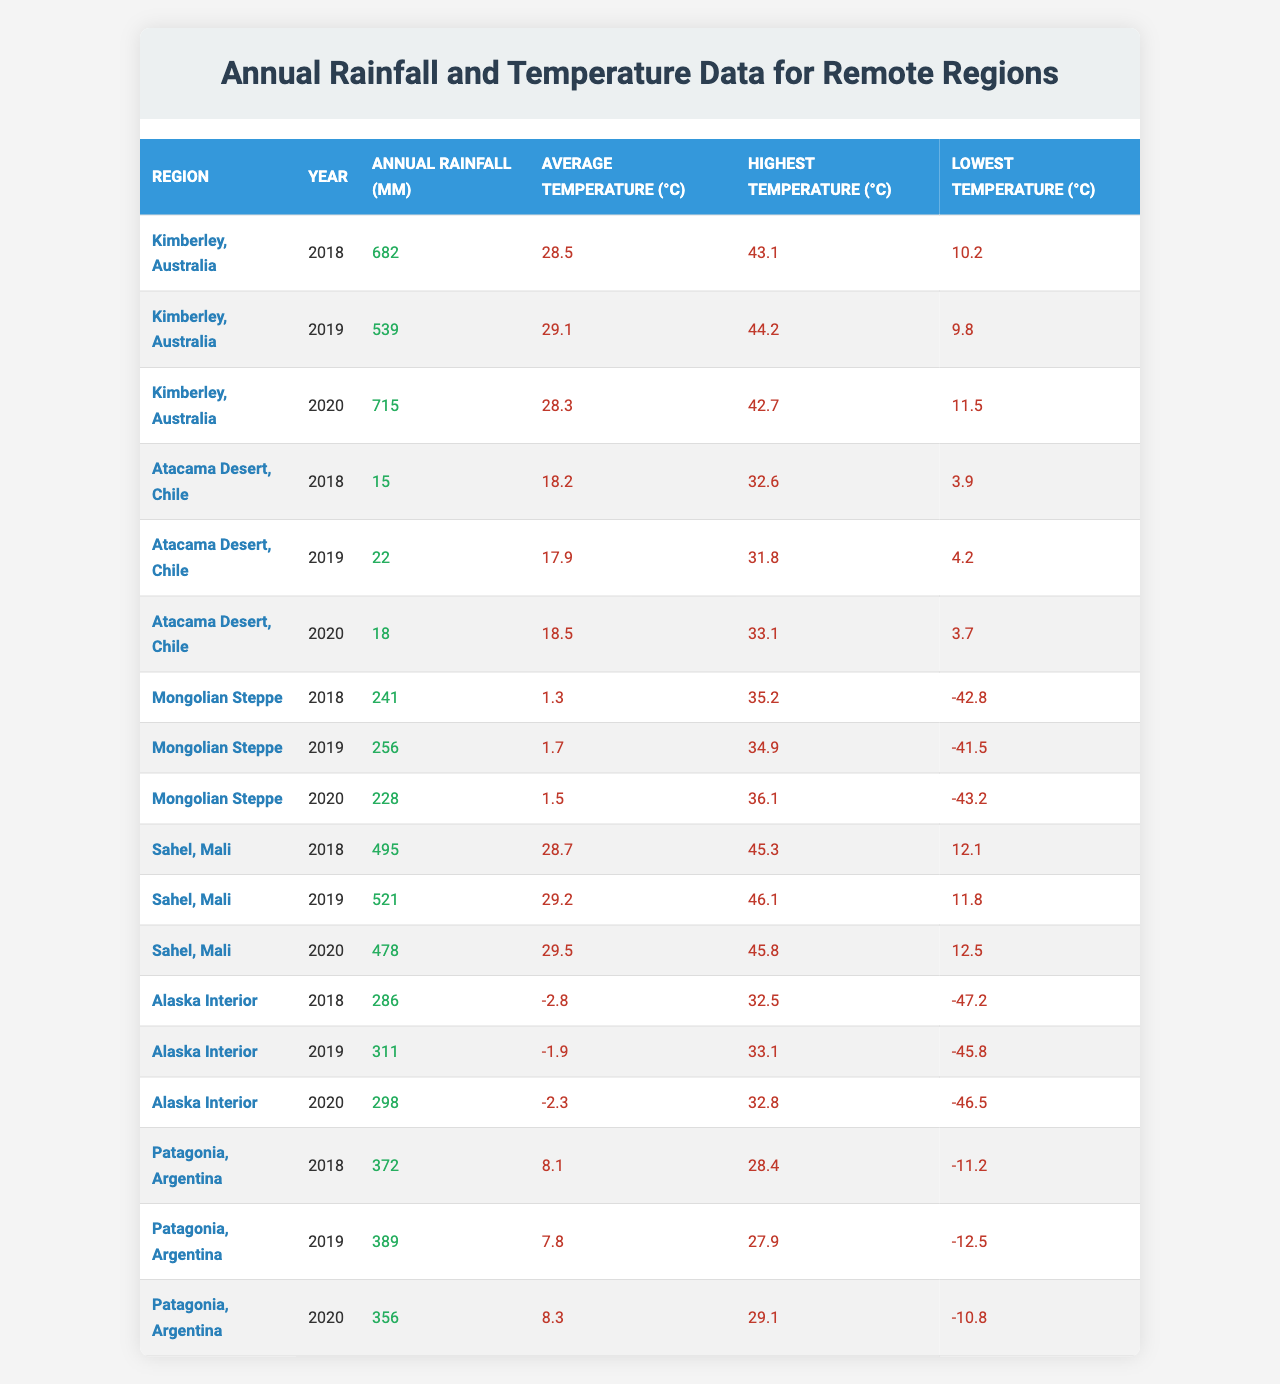What is the highest annual rainfall recorded in Kimberley, Australia? Referring to the 'Annual Rainfall (mm)' column for Kimberley, Australia, the highest recorded value is 715 mm in 2020.
Answer: 715 mm What was the average annual rainfall in the Mongolian Steppe over the three years? To find the average, sum the annual rainfall values for the Mongolian Steppe: (241 + 256 + 228) = 725 mm. Then, divide by 3: 725 mm / 3 = 241.67 mm.
Answer: 241.67 mm In what year did Alaska Interior experience the lowest average temperature? Checking the 'Average Temperature (°C)' column for Alaska Interior, the lowest average temperature is -2.8°C in 2018.
Answer: -2.8°C Was the annual rainfall in Atacama Desert, Chile, greater in 2019 or 2020? Comparing the annual rainfall values for Atacama Desert: 22 mm in 2019 and 18 mm in 2020, 2019 had a higher value.
Answer: 2019 Which region consistently had the highest average temperature over the three years? Looking at the 'Average Temperature (°C)' values, Sahel, Mali consistently had the highest values (28.7°C, 29.2°C, 29.5°C).
Answer: Sahel, Mali Is it true that Kimberley, Australia recorded more rainfall than the Atacama Desert in 2020? Kimberley recorded 715 mm in 2020, while the Atacama Desert recorded 18 mm in the same year. Therefore, it is true that Kimberley had more rainfall.
Answer: Yes What is the difference between the highest and lowest temperatures recorded in the Mongolian Steppe for the year 2018? The highest temperature in 2018 is 35.2°C and the lowest is -42.8°C. The difference is 35.2°C - (-42.8°C) = 35.2°C + 42.8°C = 78°C.
Answer: 78°C What region saw the largest decline in annual rainfall from 2019 to 2020? The rainfall amounts in 2019 and 2020 for Sahel, Mali are 521 mm and 478 mm respectively. The decline is 521 mm - 478 mm = 43 mm, which is the largest among the regions.
Answer: Sahel, Mali 